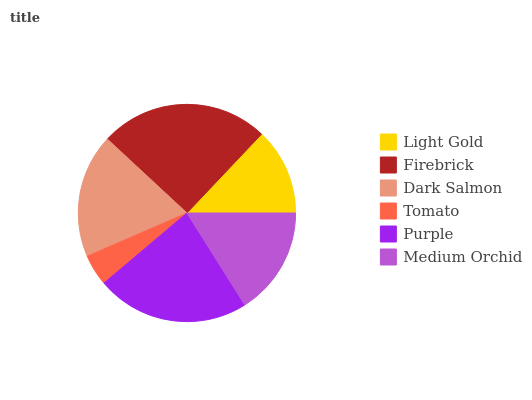Is Tomato the minimum?
Answer yes or no. Yes. Is Firebrick the maximum?
Answer yes or no. Yes. Is Dark Salmon the minimum?
Answer yes or no. No. Is Dark Salmon the maximum?
Answer yes or no. No. Is Firebrick greater than Dark Salmon?
Answer yes or no. Yes. Is Dark Salmon less than Firebrick?
Answer yes or no. Yes. Is Dark Salmon greater than Firebrick?
Answer yes or no. No. Is Firebrick less than Dark Salmon?
Answer yes or no. No. Is Dark Salmon the high median?
Answer yes or no. Yes. Is Medium Orchid the low median?
Answer yes or no. Yes. Is Tomato the high median?
Answer yes or no. No. Is Purple the low median?
Answer yes or no. No. 